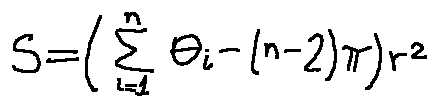<formula> <loc_0><loc_0><loc_500><loc_500>S = ( \sum \lim i t s _ { i = 1 } ^ { n } \theta _ { i } - ( n - 2 ) \pi ) r ^ { 2 }</formula> 